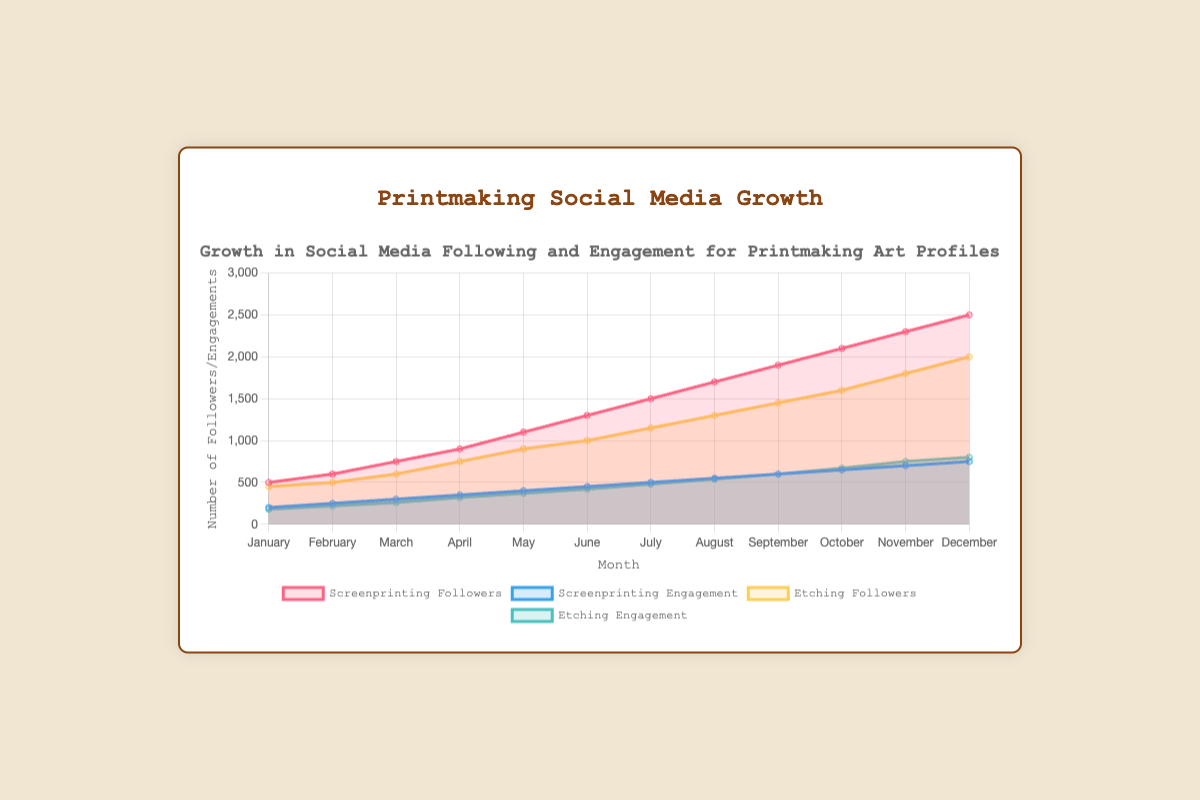What's the title of the chart? The title of the chart is located at the top center and provides a concise description of the chart content.
Answer: Growth in Social Media Following and Engagement for Printmaking Art Profiles How many months are represented in the chart? The x-axis displays the timeline with labeled months, which can be counted to determine the number of data points.
Answer: 12 Which type of activity has the highest number of followers in December? Compare the data points for "Screenprinting Followers" and "Etching Followers" in the month of December shown on the chart. "Screenprinting Followers" shows a higher value.
Answer: Screenprinting Followers By how much has the engagement increased from January to December for etching? Subtract the engagement value in January from the value in December for etching: 800 - 180 = 620.
Answer: 620 What is the average monthly engagement for screenprinting across the year? Sum all monthly engagement values for screenprinting and divide by the number of months: (200 + 250 + 300 + 350 + 400 + 450 + 500 + 550 + 600 + 650 + 700 + 750) / 12 = 475.
Answer: 475 Which month saw the largest increase in followers for screenprinting from the previous month? Calculate the month-over-month difference for screenprinting followers and identify the maximum: March-April (900-750=150), April-May (1100-900=200), May-June (1300-1100=200). So, the largest increase is from April to May.
Answer: April to May In which month were the engagements for etching higher than those for screenprinting? For each month, compare the etching engagement data point with the screenprinting engagement data point. The month where etching engagement is higher is October.
Answer: October What's the total number of followers for etching at the end of the year? The total number of followers for etching in December is provided as the last data point for "Etching Followers".
Answer: 2000 How does the growth trend of followers compare between screenprinting and etching? Evaluate the overall slopes and changes in the trend lines for both screenprinting and etching followers. Screenprinting follows a steeper, more consistent upward trend compared to etching, which also shows a steady but slightly less steep increase.
Answer: Screenprinting shows a steeper upward trend How does the engagement for screenprinting in August compare with the engagement for etching in the same month? Identify the engagement values for both screenprinting and etching in August, and then compare: screenprinting engagement is 550, etching engagement is 540.
Answer: Screenprinting engagement is higher 